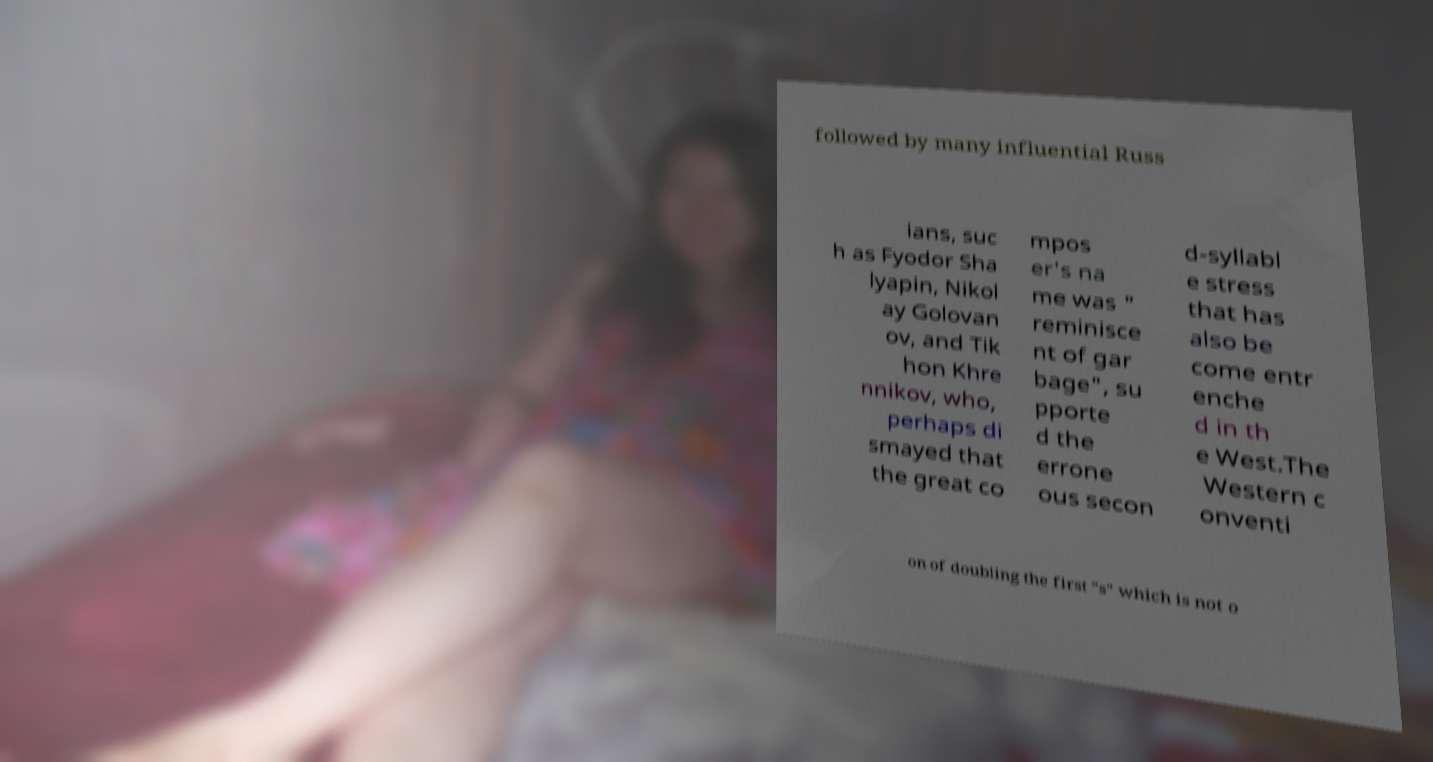Could you extract and type out the text from this image? followed by many influential Russ ians, suc h as Fyodor Sha lyapin, Nikol ay Golovan ov, and Tik hon Khre nnikov, who, perhaps di smayed that the great co mpos er's na me was " reminisce nt of gar bage", su pporte d the errone ous secon d-syllabl e stress that has also be come entr enche d in th e West.The Western c onventi on of doubling the first "s" which is not o 